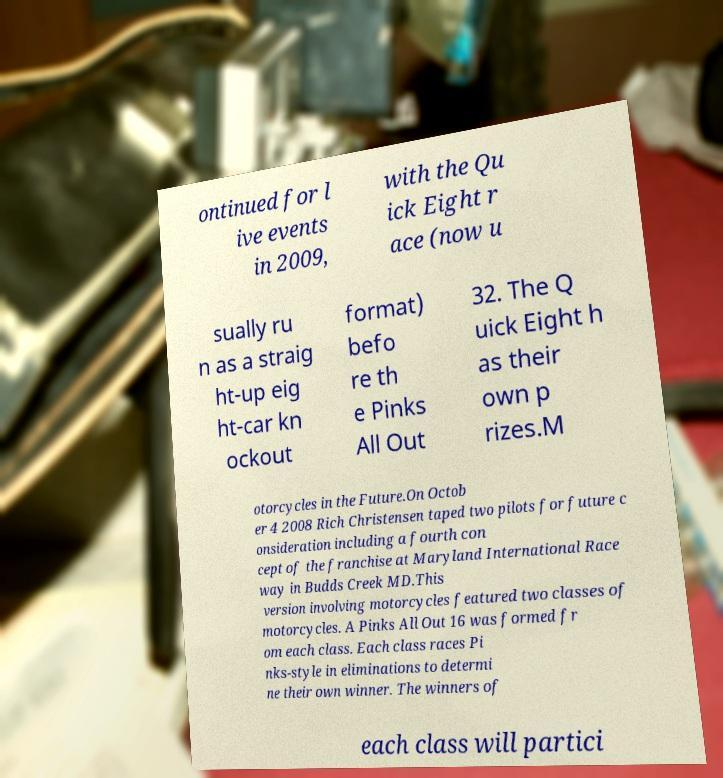Please read and relay the text visible in this image. What does it say? ontinued for l ive events in 2009, with the Qu ick Eight r ace (now u sually ru n as a straig ht-up eig ht-car kn ockout format) befo re th e Pinks All Out 32. The Q uick Eight h as their own p rizes.M otorcycles in the Future.On Octob er 4 2008 Rich Christensen taped two pilots for future c onsideration including a fourth con cept of the franchise at Maryland International Race way in Budds Creek MD.This version involving motorcycles featured two classes of motorcycles. A Pinks All Out 16 was formed fr om each class. Each class races Pi nks-style in eliminations to determi ne their own winner. The winners of each class will partici 